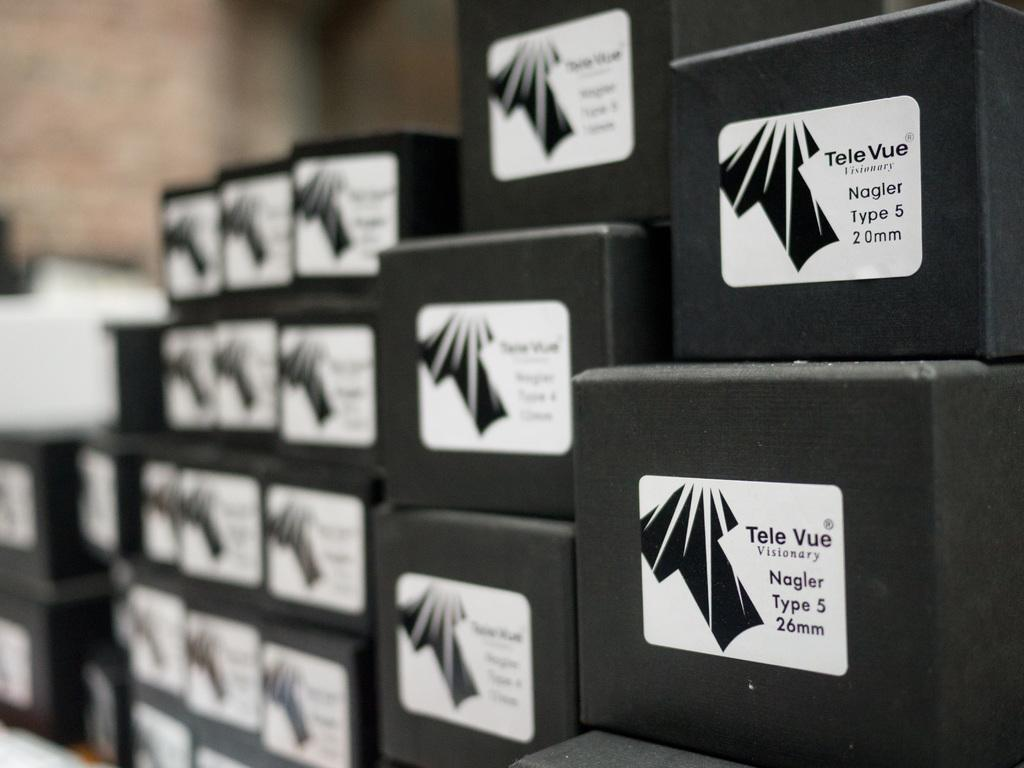What objects can be seen in the image? There are boxes in the image. Can you describe the background of the image? The background of the image is blurry. What type of brass instrument is being played in the image? There is no brass instrument or any musical instrument present in the image; it only contains boxes and a blurry background. 